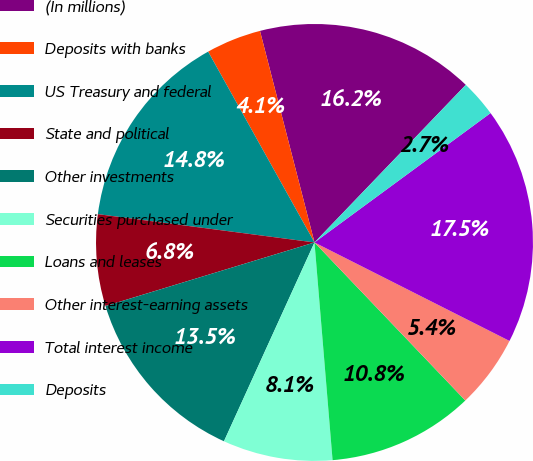<chart> <loc_0><loc_0><loc_500><loc_500><pie_chart><fcel>(In millions)<fcel>Deposits with banks<fcel>US Treasury and federal<fcel>State and political<fcel>Other investments<fcel>Securities purchased under<fcel>Loans and leases<fcel>Other interest-earning assets<fcel>Total interest income<fcel>Deposits<nl><fcel>16.19%<fcel>4.08%<fcel>14.84%<fcel>6.77%<fcel>13.5%<fcel>8.12%<fcel>10.81%<fcel>5.43%<fcel>17.53%<fcel>2.74%<nl></chart> 